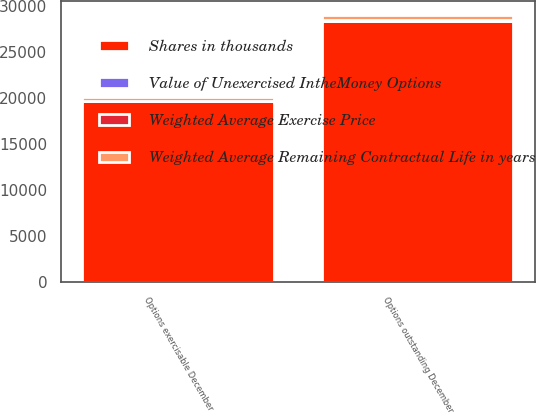Convert chart. <chart><loc_0><loc_0><loc_500><loc_500><stacked_bar_chart><ecel><fcel>Options outstanding December<fcel>Options exercisable December<nl><fcel>Shares in thousands<fcel>28374<fcel>19612<nl><fcel>Value of Unexercised IntheMoney Options<fcel>57<fcel>55<nl><fcel>Weighted Average Exercise Price<fcel>4<fcel>3<nl><fcel>Weighted Average Remaining Contractual Life in years<fcel>586<fcel>456<nl></chart> 